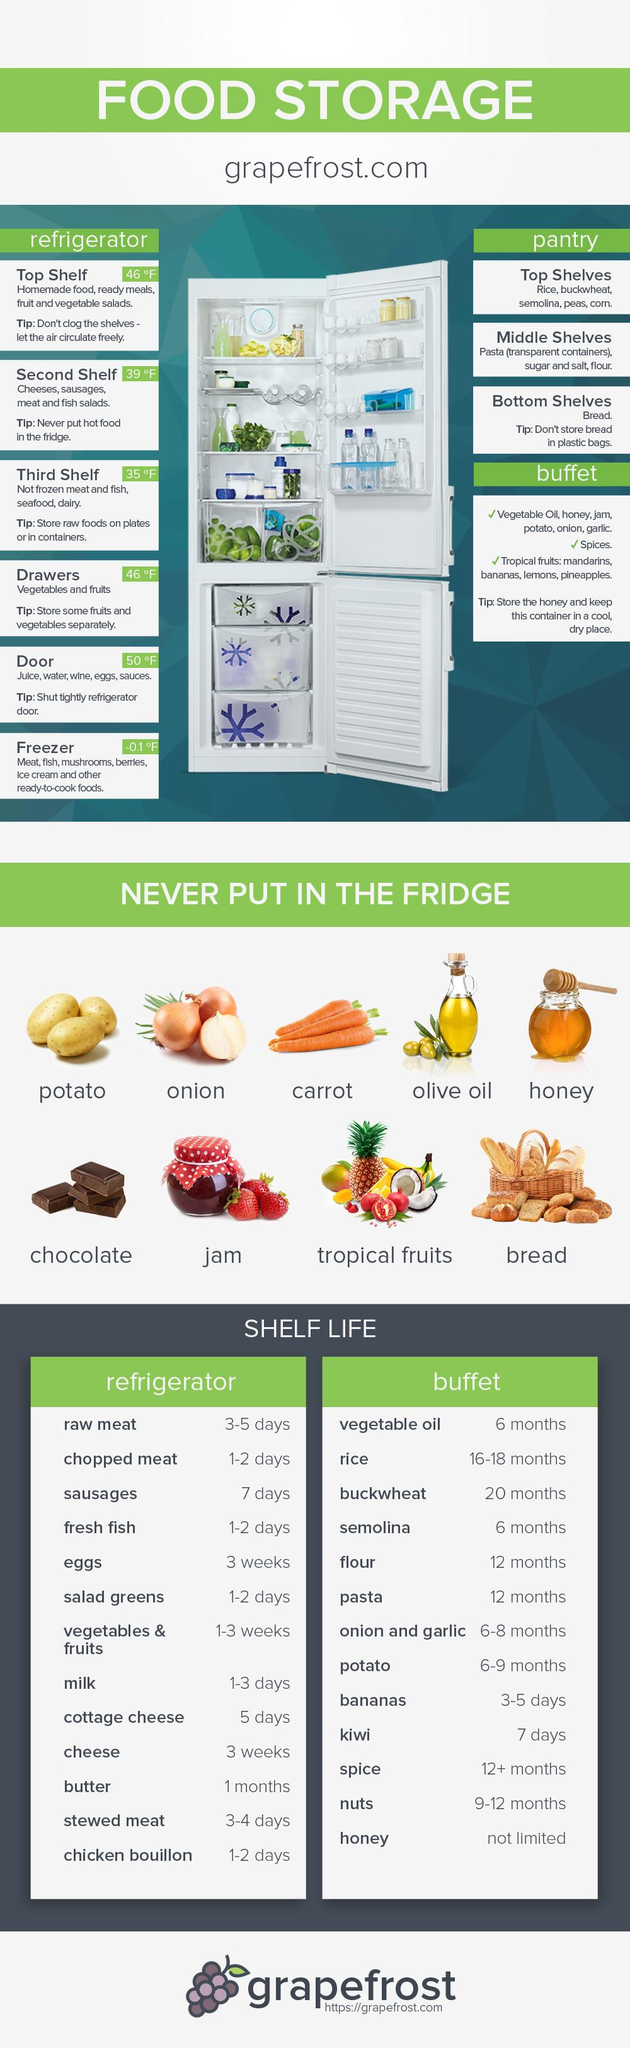Draw attention to some important aspects in this diagram. Bread should be stored in the bottom shelves of the pantry. Fruits and vegetables should be stored in the drawers of the refrigerator for optimal freshness and safety. Cheese, sausage, meat, and fish salad should be stored on the second shelf. Rice, semolina, buckwheat, and other grains should be stored in the pantry rather than the refrigerator. Butter is the dairy product with the highest shelf life among those listed. 